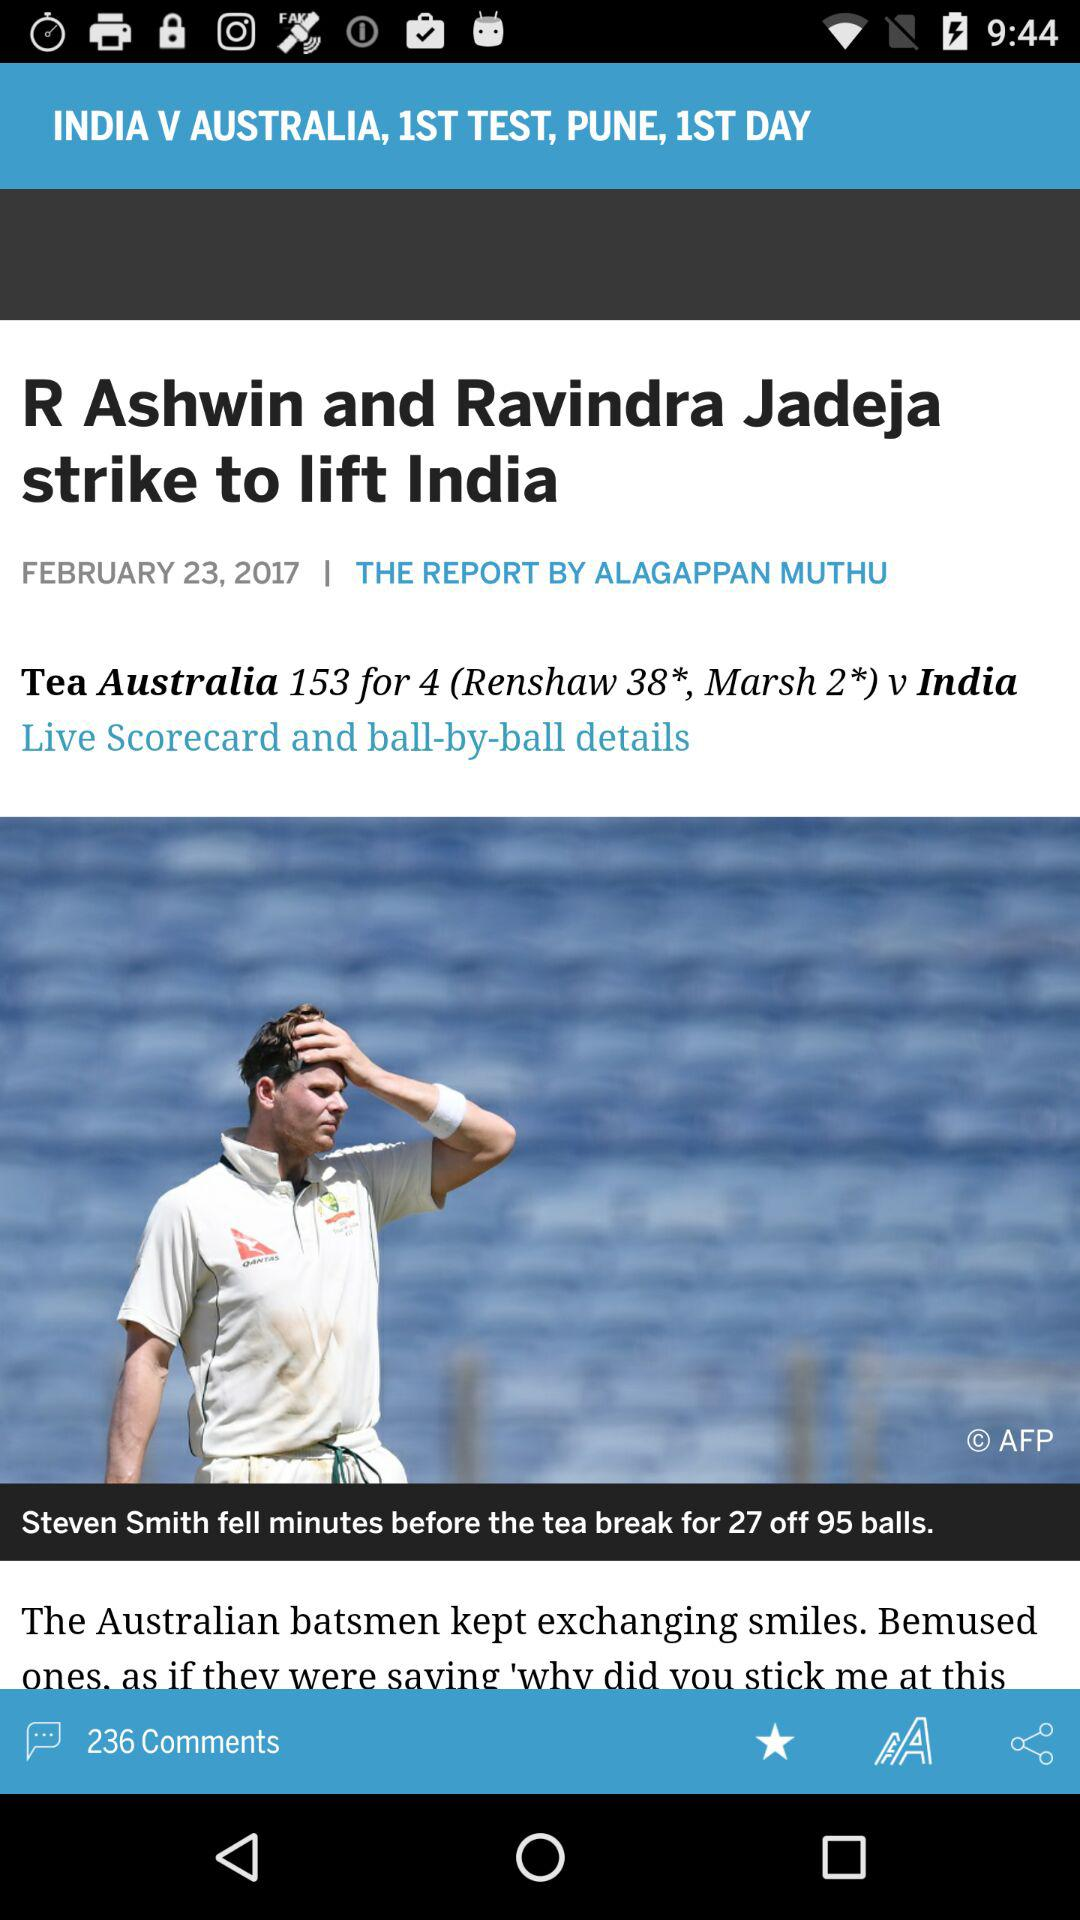Which teams are competing in the match? The teams are "INDIA" and "AUSTRALIA". 